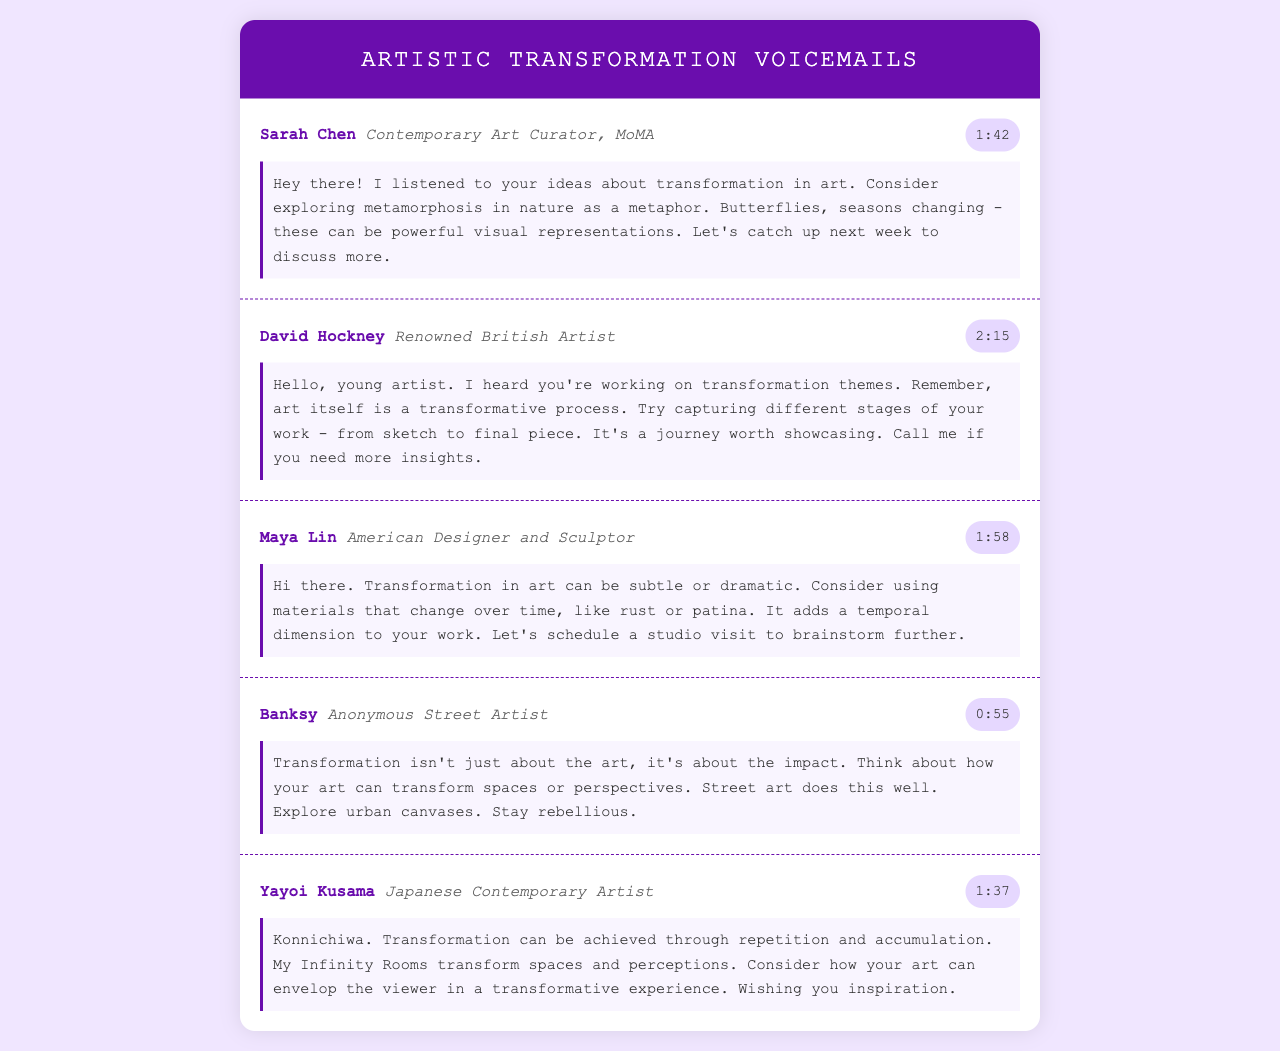What is the duration of Sarah Chen's voicemail? The duration of Sarah Chen's voicemail is listed right next to her name in the document.
Answer: 1:42 Who is the renowned British artist mentioned in the voicemails? The document contains names of various artists, including the renowned British artist.
Answer: David Hockney What key metaphor does Sarah Chen suggest for exploring transformation? The voicemail contains insights and suggestions related to transformation and identifies metaphors for artistic inspiration.
Answer: Metamorphosis in nature Which artist discusses the transformative process of art itself? Each voicemail offers different perspectives, and one in particular mentions the transformative nature of art as a process.
Answer: David Hockney How does Maya Lin suggest incorporating material changes into artwork? Her voicemail mentions a specific approach regarding materials in artwork to enhance transformation, leading to a temporal dimension.
Answer: Rust or patina What is a theme Banksy emphasizes about transformation in art? The document covers various artists' perspectives, including Banksy's thoughts on the broader implications of art.
Answer: Impact What experience does Yayoi Kusama aim to create through her art? Yayoi Kusama reflects on how her work transforms viewer perceptions, which is highlighted in her voicemail message.
Answer: Transformative experience How many voicemails are recorded in the document? The number of voicemails can be counted from the document content.
Answer: Five 